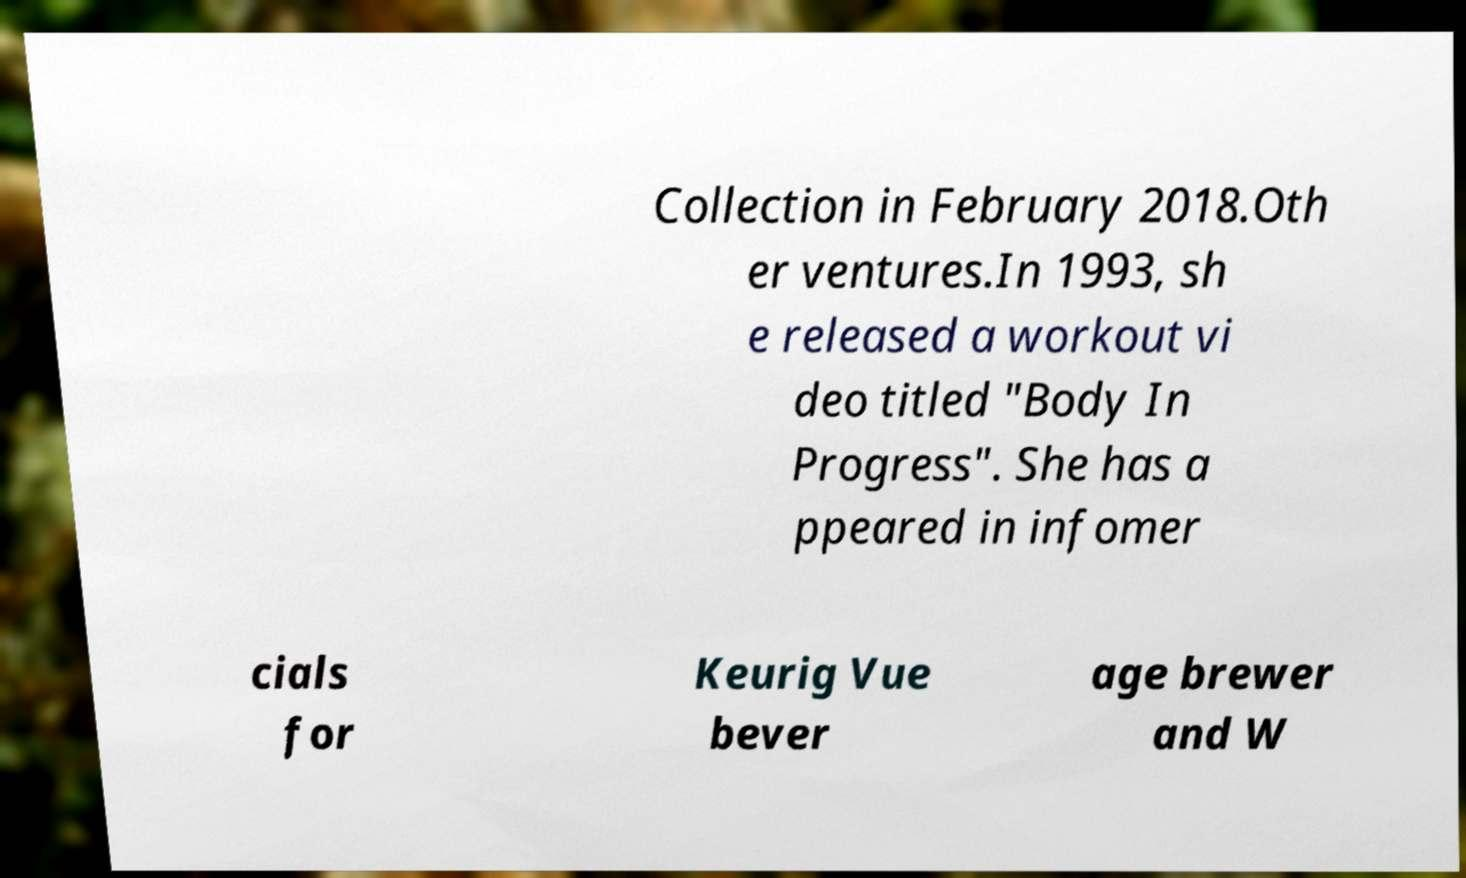I need the written content from this picture converted into text. Can you do that? Collection in February 2018.Oth er ventures.In 1993, sh e released a workout vi deo titled "Body In Progress". She has a ppeared in infomer cials for Keurig Vue bever age brewer and W 